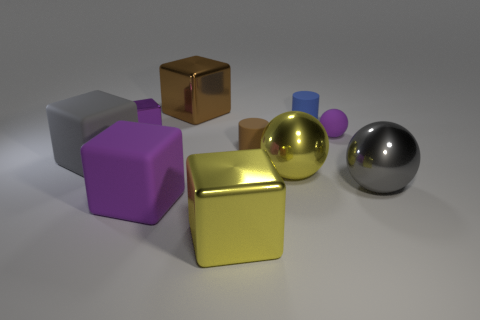What number of other things are there of the same material as the big purple block
Give a very brief answer. 4. Does the small metal cube have the same color as the tiny rubber sphere?
Provide a short and direct response. Yes. Are there any balls that have the same size as the gray rubber block?
Offer a terse response. Yes. What is the size of the cylinder to the left of the cylinder that is on the right side of the tiny brown object?
Offer a terse response. Small. What number of big cubes are the same color as the tiny metallic thing?
Give a very brief answer. 1. There is a tiny thing that is to the left of the small rubber thing that is on the left side of the tiny blue thing; what is its shape?
Provide a short and direct response. Cube. What number of gray things are the same material as the tiny ball?
Offer a very short reply. 1. There is a yellow object in front of the gray sphere; what material is it?
Provide a succinct answer. Metal. There is a metallic thing on the left side of the purple rubber thing in front of the big rubber cube to the left of the tiny purple metal object; what shape is it?
Provide a succinct answer. Cube. Does the big metal object that is in front of the gray shiny object have the same color as the big sphere that is on the left side of the blue thing?
Provide a short and direct response. Yes. 